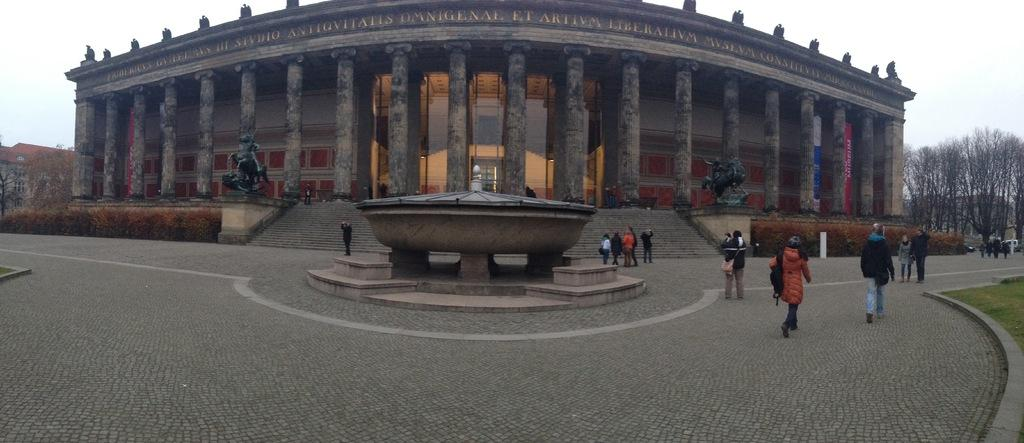How many people are in the image? There is a group of people in the image, but the exact number is not specified. What are some of the people in the image doing? Some people are standing, and some are walking. What can be seen in the background of the image? There are trees, statues, and buildings in the background of the image. What type of cough medicine is being recommended by the statues in the image? There is no cough medicine or recommendation present in the image. The statues are simply part of the background and not interacting with the people or the scene in any way. 